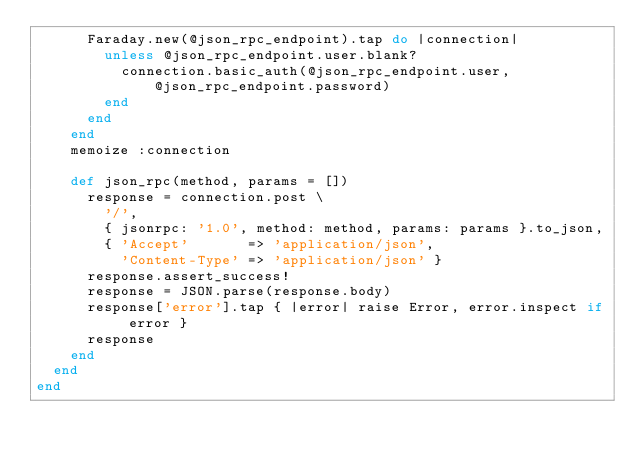Convert code to text. <code><loc_0><loc_0><loc_500><loc_500><_Ruby_>      Faraday.new(@json_rpc_endpoint).tap do |connection|
        unless @json_rpc_endpoint.user.blank?
          connection.basic_auth(@json_rpc_endpoint.user, @json_rpc_endpoint.password)
        end
      end
    end
    memoize :connection

    def json_rpc(method, params = [])
      response = connection.post \
        '/',
        { jsonrpc: '1.0', method: method, params: params }.to_json,
        { 'Accept'       => 'application/json',
          'Content-Type' => 'application/json' }
      response.assert_success!
      response = JSON.parse(response.body)
      response['error'].tap { |error| raise Error, error.inspect if error }
      response
    end
  end
end
</code> 